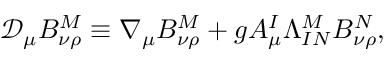<formula> <loc_0><loc_0><loc_500><loc_500>\mathcal { D } _ { \mu } B _ { \nu \rho } ^ { M } \equiv \nabla _ { \mu } B _ { \nu \rho } ^ { M } + g A _ { \mu } ^ { I } \Lambda _ { I N } ^ { M } B _ { \nu \rho } ^ { N } ,</formula> 